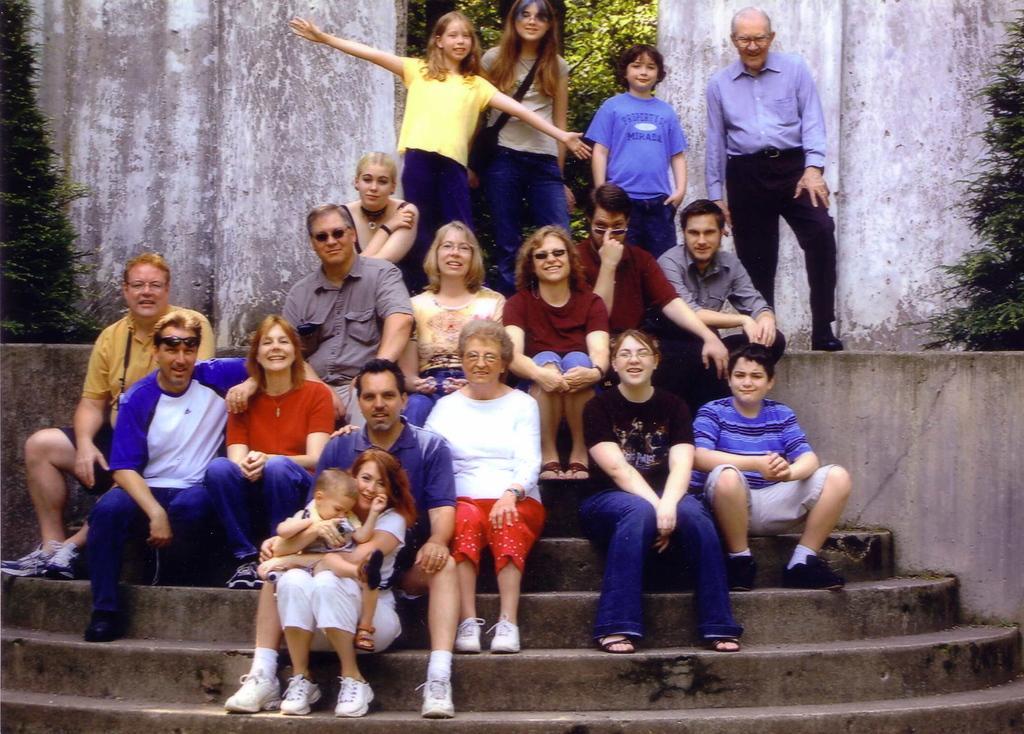Please provide a concise description of this image. In the picture we can see some family members are sitting on the steps with their children and behind them, we can see four people are standing, and behind them, we can see the wall and on the either sides of the wall we can see plants. 